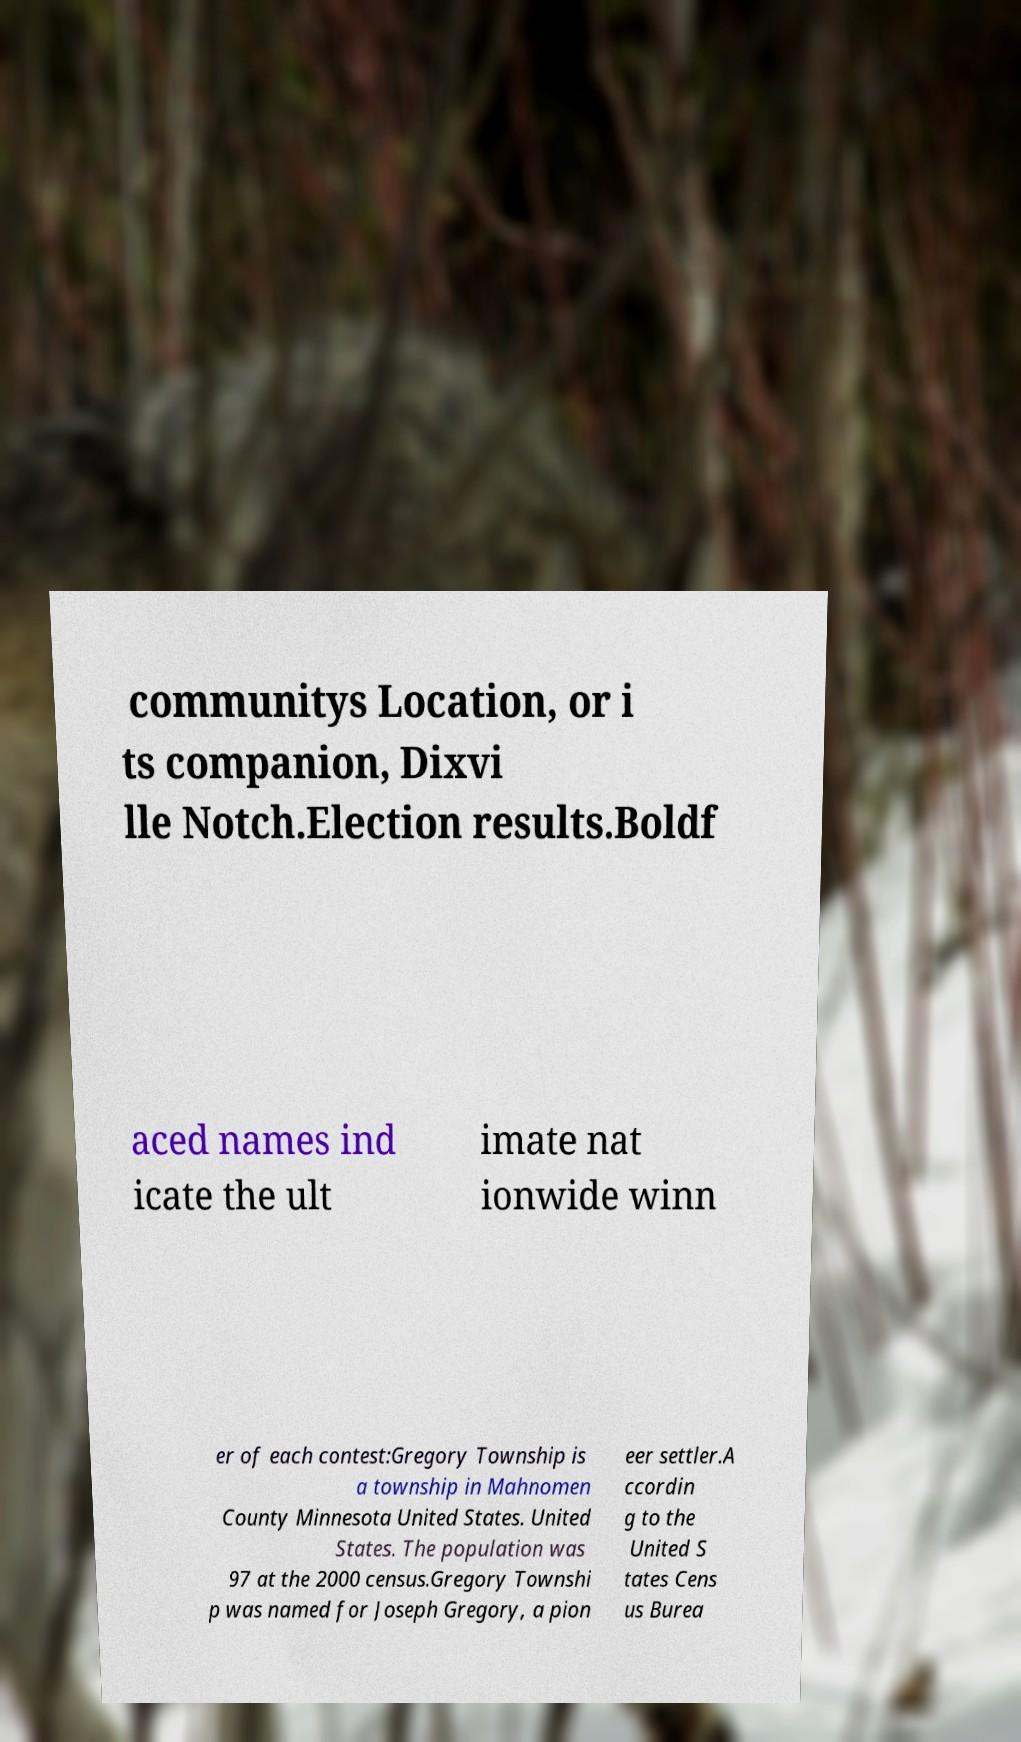There's text embedded in this image that I need extracted. Can you transcribe it verbatim? communitys Location, or i ts companion, Dixvi lle Notch.Election results.Boldf aced names ind icate the ult imate nat ionwide winn er of each contest:Gregory Township is a township in Mahnomen County Minnesota United States. United States. The population was 97 at the 2000 census.Gregory Townshi p was named for Joseph Gregory, a pion eer settler.A ccordin g to the United S tates Cens us Burea 